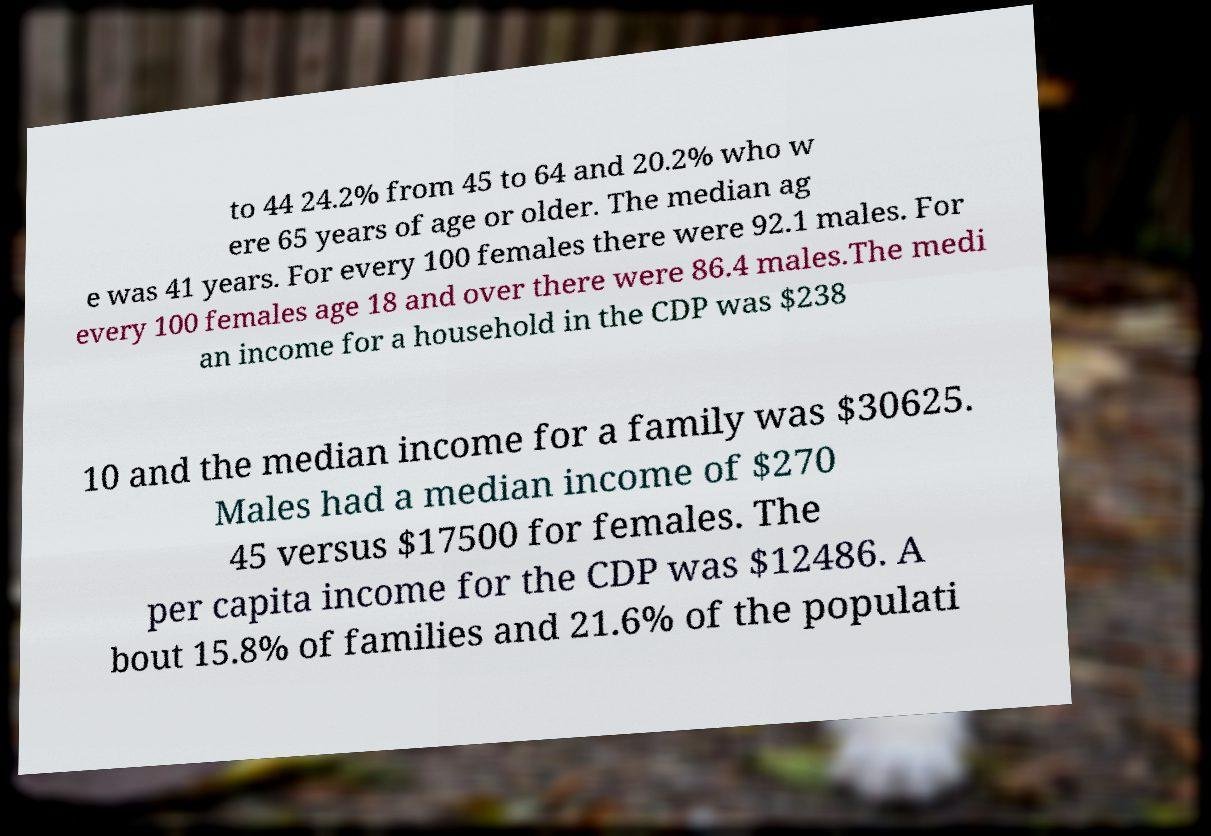Could you extract and type out the text from this image? to 44 24.2% from 45 to 64 and 20.2% who w ere 65 years of age or older. The median ag e was 41 years. For every 100 females there were 92.1 males. For every 100 females age 18 and over there were 86.4 males.The medi an income for a household in the CDP was $238 10 and the median income for a family was $30625. Males had a median income of $270 45 versus $17500 for females. The per capita income for the CDP was $12486. A bout 15.8% of families and 21.6% of the populati 